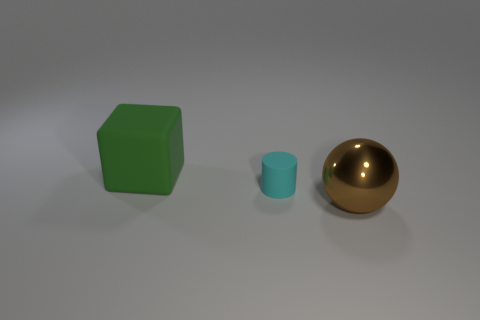Add 3 small green rubber blocks. How many objects exist? 6 Subtract 1 cubes. How many cubes are left? 0 Subtract all small yellow rubber blocks. Subtract all big brown spheres. How many objects are left? 2 Add 3 large brown objects. How many large brown objects are left? 4 Add 1 cyan matte objects. How many cyan matte objects exist? 2 Subtract 0 yellow blocks. How many objects are left? 3 Subtract all spheres. How many objects are left? 2 